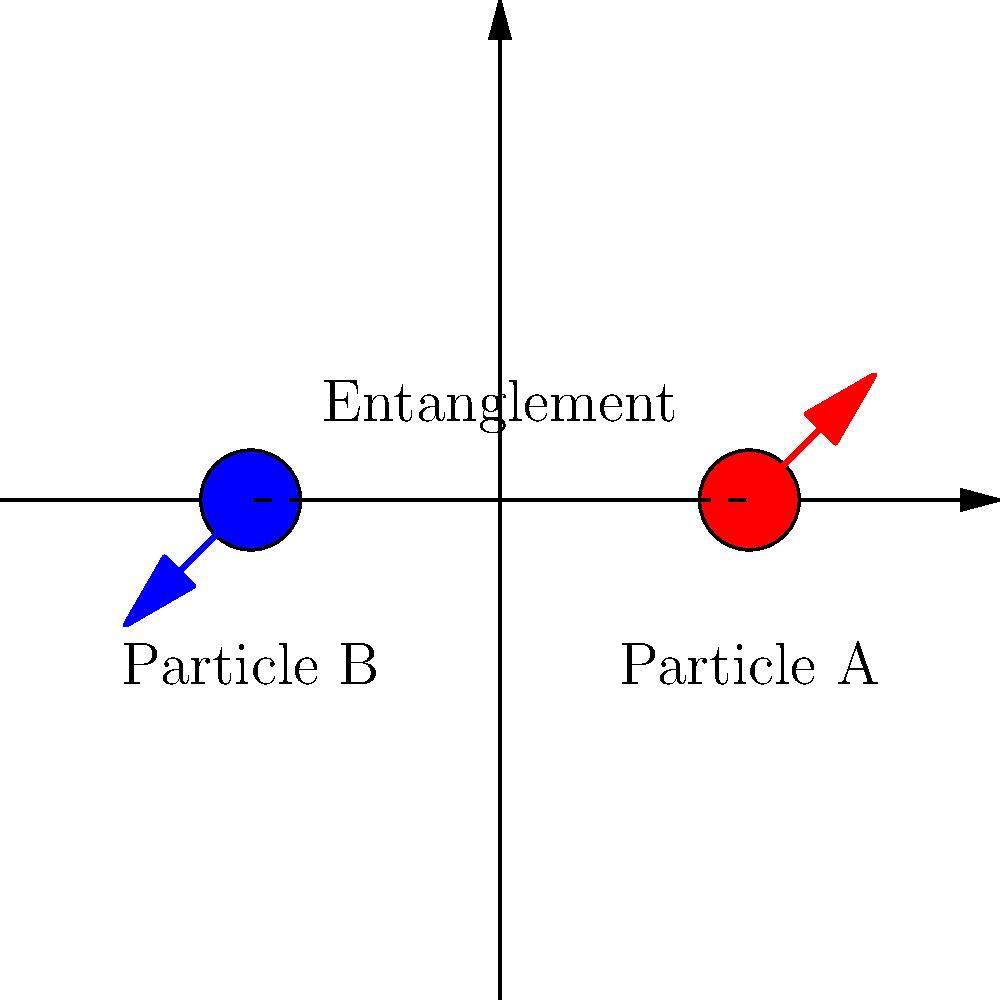In the diagram above, two entangled particles are represented. If a measurement on Particle A results in an upward spin, what can be inferred about the spin of Particle B, and how does this demonstrate the non-local nature of quantum entanglement? To understand this scenario, let's break it down step-by-step:

1. Quantum Entanglement: The two particles (A and B) are entangled, meaning their quantum states are correlated, regardless of the distance between them.

2. Spin Measurement: When we measure the spin of Particle A and find it to be upward (as shown in the diagram), due to the principles of quantum mechanics, specifically the conservation of angular momentum, we can immediately infer information about Particle B.

3. Conservation of Angular Momentum: In an entangled pair, the total spin must be conserved. If the particles were prepared in a singlet state (total spin zero), their spins must be opposite.

4. Instantaneous Effect: The moment we measure Particle A's spin as upward, Particle B's spin is instantaneously determined to be downward, regardless of the distance between them.

5. Non-locality: This instantaneous determination of Particle B's state, without any direct interaction or classical communication, demonstrates the non-local nature of quantum entanglement.

6. Einstein's "Spooky Action at a Distance": This phenomenon was famously described by Einstein as "spooky action at a distance" because it seems to violate classical principles of locality and causality.

7. No Faster-Than-Light Communication: Despite this instantaneous correlation, it's important to note that this cannot be used for faster-than-light communication, as the outcome of each individual measurement is random.
Answer: Particle B's spin will be downward, demonstrating non-local quantum correlation. 